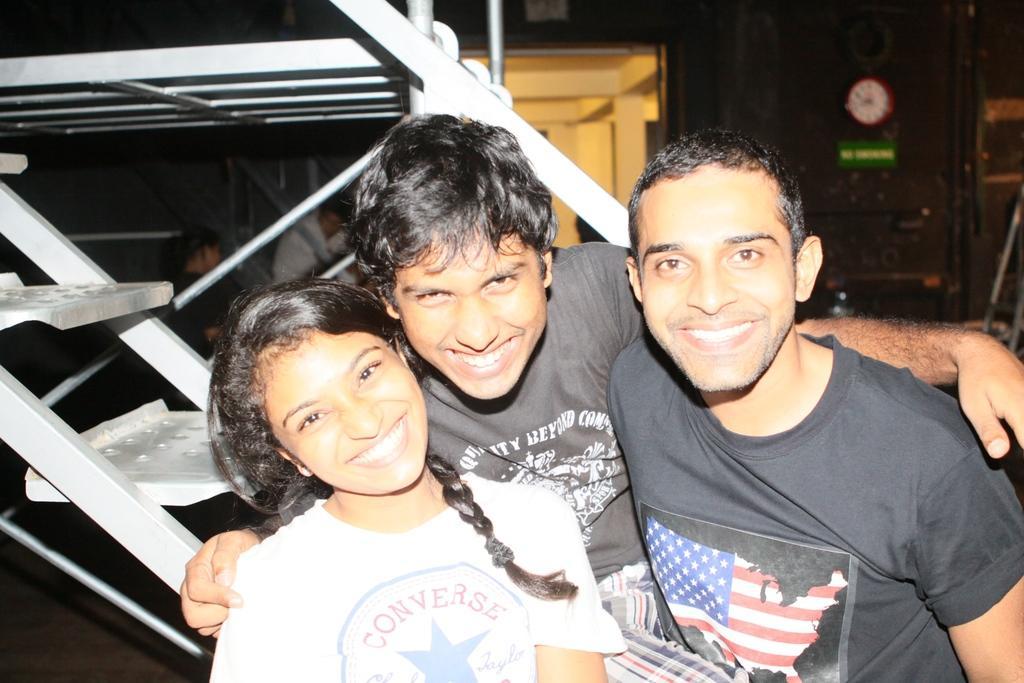Please provide a concise description of this image. In this image I can see three persons smiling and posing. There are two other persons, there is a clock, name board and there are some objects in the background. 